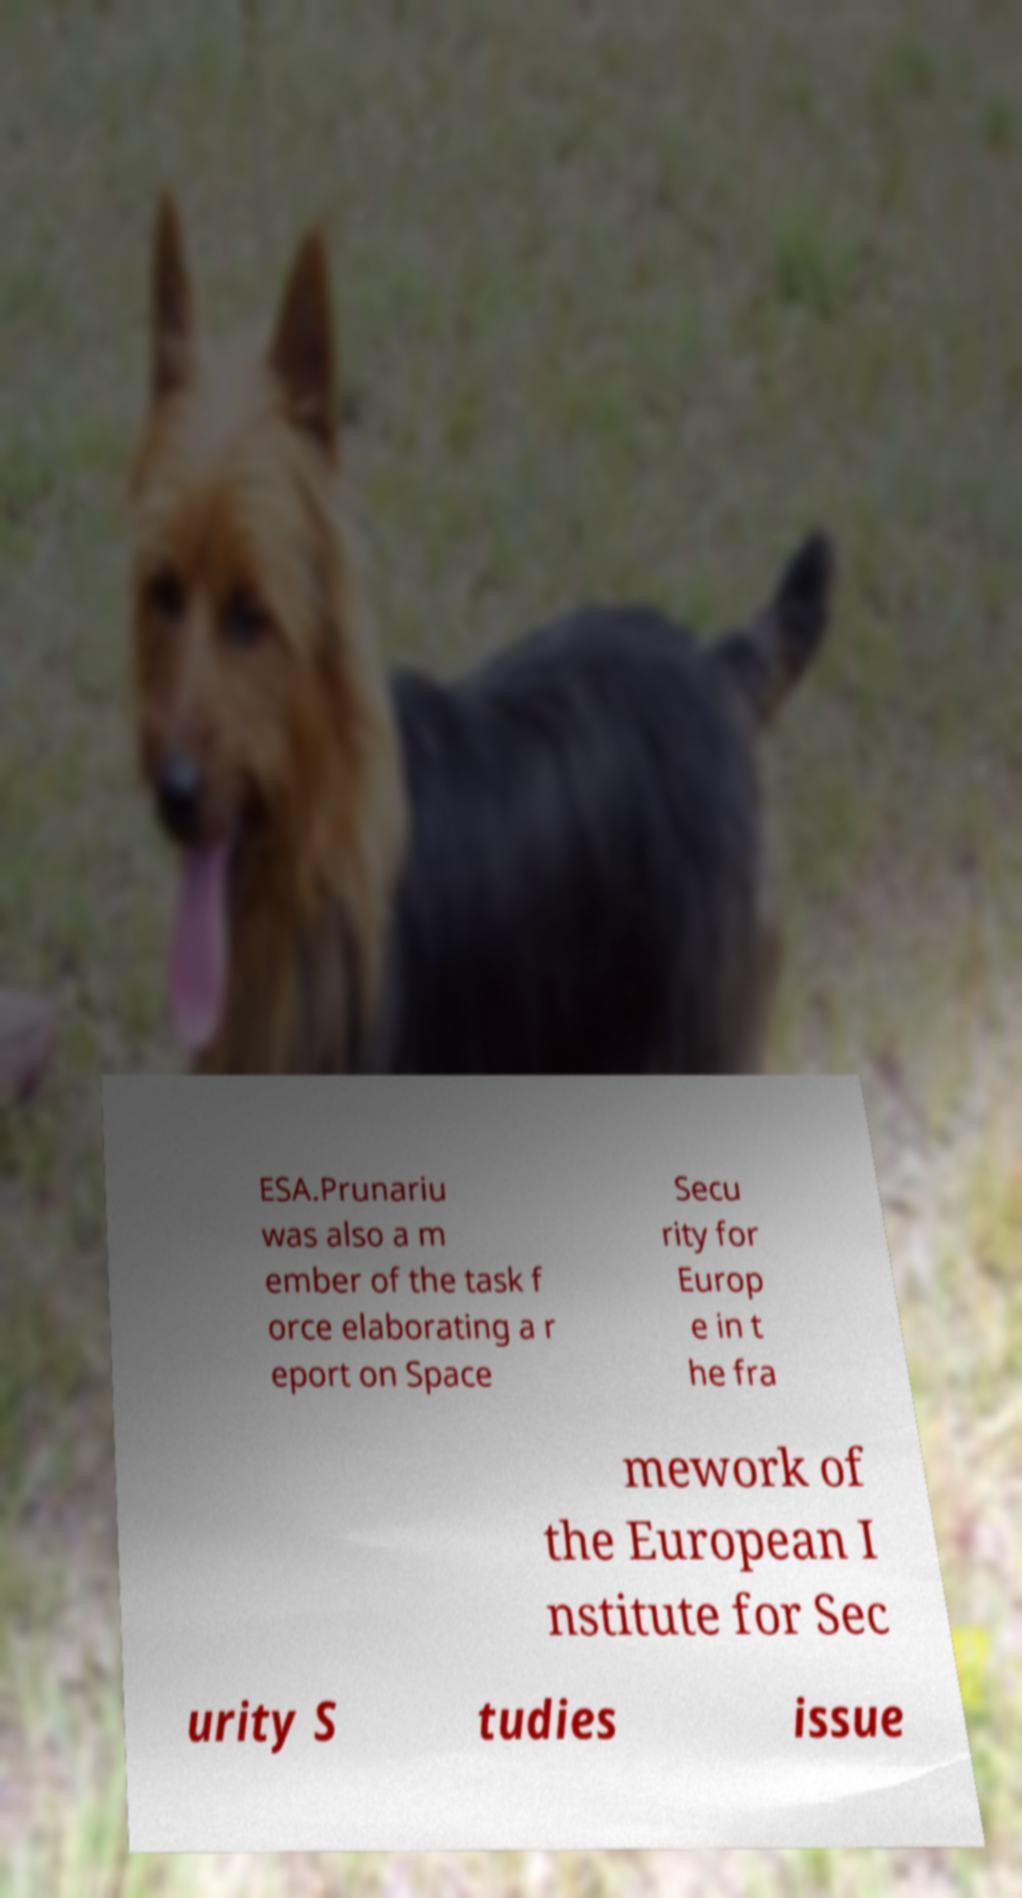Could you extract and type out the text from this image? ESA.Prunariu was also a m ember of the task f orce elaborating a r eport on Space Secu rity for Europ e in t he fra mework of the European I nstitute for Sec urity S tudies issue 